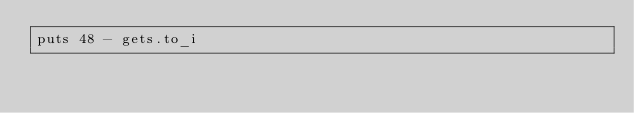<code> <loc_0><loc_0><loc_500><loc_500><_Ruby_>puts 48 - gets.to_i </code> 